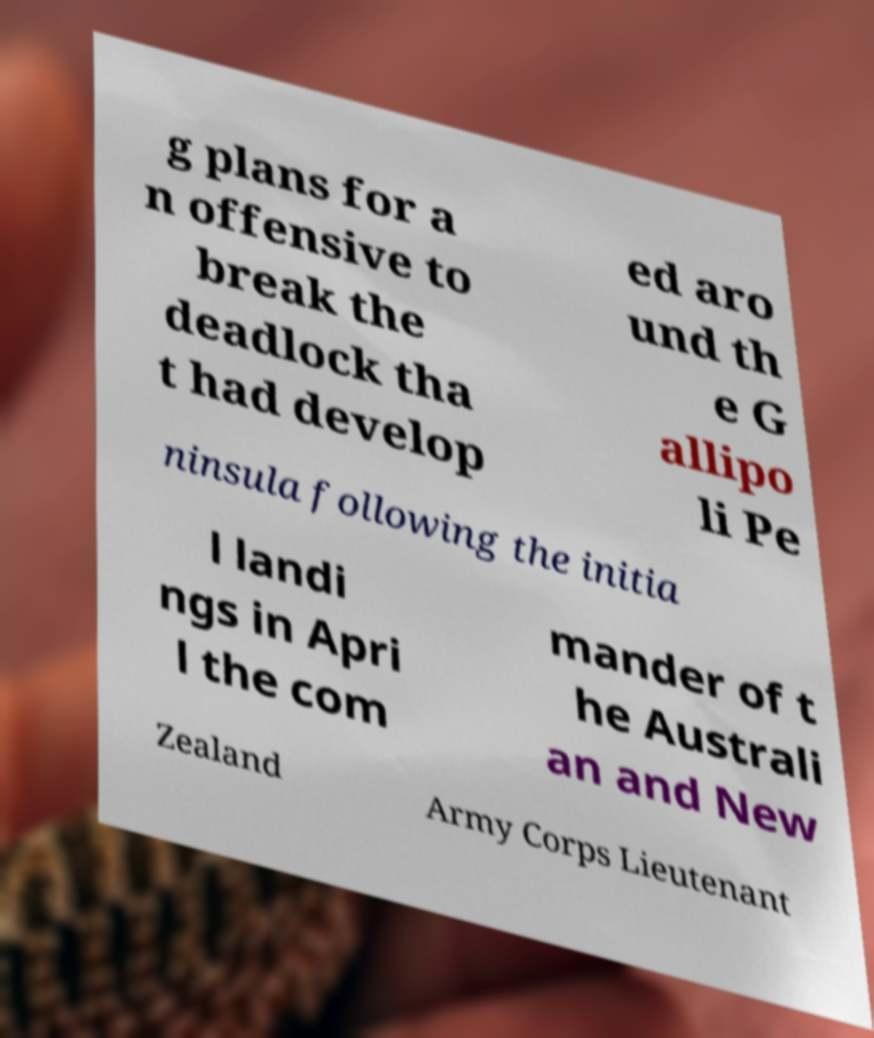Could you assist in decoding the text presented in this image and type it out clearly? g plans for a n offensive to break the deadlock tha t had develop ed aro und th e G allipo li Pe ninsula following the initia l landi ngs in Apri l the com mander of t he Australi an and New Zealand Army Corps Lieutenant 